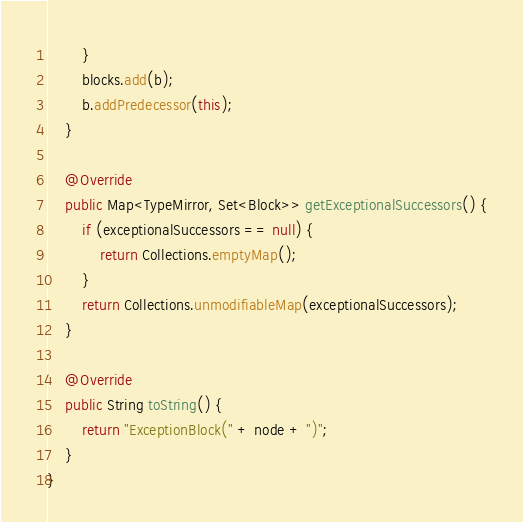<code> <loc_0><loc_0><loc_500><loc_500><_Java_>        }
        blocks.add(b);
        b.addPredecessor(this);
    }

    @Override
    public Map<TypeMirror, Set<Block>> getExceptionalSuccessors() {
        if (exceptionalSuccessors == null) {
            return Collections.emptyMap();
        }
        return Collections.unmodifiableMap(exceptionalSuccessors);
    }

    @Override
    public String toString() {
        return "ExceptionBlock(" + node + ")";
    }
}
</code> 